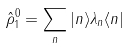<formula> <loc_0><loc_0><loc_500><loc_500>\hat { \rho } _ { 1 } ^ { 0 } = \sum _ { n } | n \rangle \lambda _ { n } \langle n |</formula> 